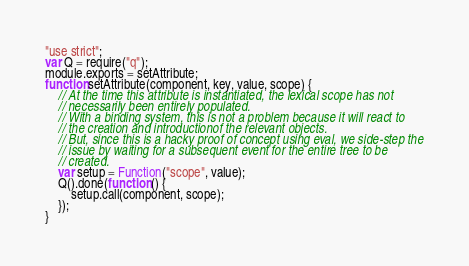<code> <loc_0><loc_0><loc_500><loc_500><_JavaScript_>"use strict";
var Q = require("q");
module.exports = setAttribute;
function setAttribute(component, key, value, scope) {
    // At the time this attribute is instantiated, the lexical scope has not
    // necessarily been entirely populated.
    // With a binding system, this is not a problem because it will react to
    // the creation and introductionof the relevant objects.
    // But, since this is a hacky proof of concept using eval, we side-step the
    // issue by waiting for a subsequent event for the entire tree to be
    // created.
    var setup = Function("scope", value);
    Q().done(function () {
        setup.call(component, scope);
    });
}
</code> 